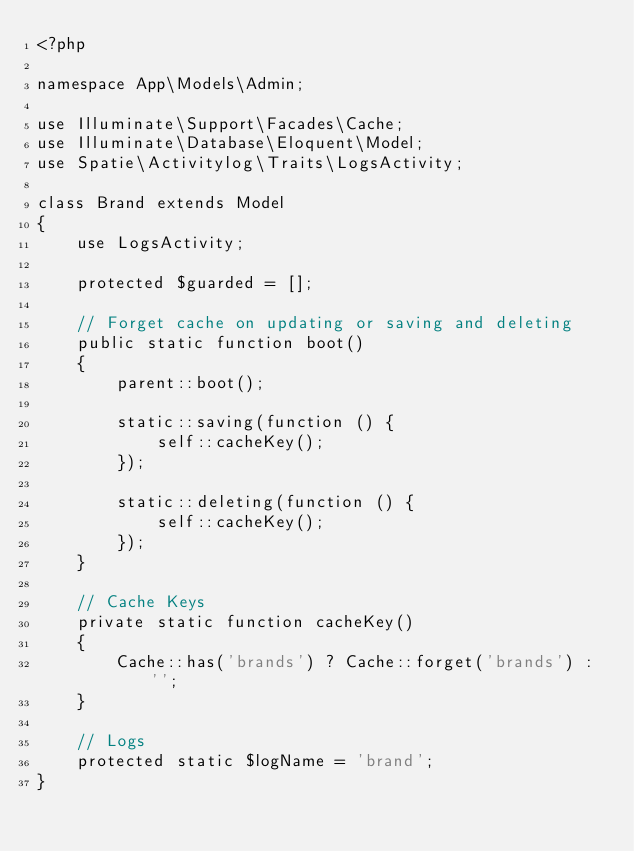Convert code to text. <code><loc_0><loc_0><loc_500><loc_500><_PHP_><?php

namespace App\Models\Admin;

use Illuminate\Support\Facades\Cache;
use Illuminate\Database\Eloquent\Model;
use Spatie\Activitylog\Traits\LogsActivity;

class Brand extends Model
{
    use LogsActivity;

    protected $guarded = [];

    // Forget cache on updating or saving and deleting
    public static function boot()
    {
        parent::boot();

        static::saving(function () {
            self::cacheKey();
        });

        static::deleting(function () {
            self::cacheKey();
        });
    }

    // Cache Keys
    private static function cacheKey()
    {
        Cache::has('brands') ? Cache::forget('brands') : '';
    }

    // Logs
    protected static $logName = 'brand';
}
</code> 